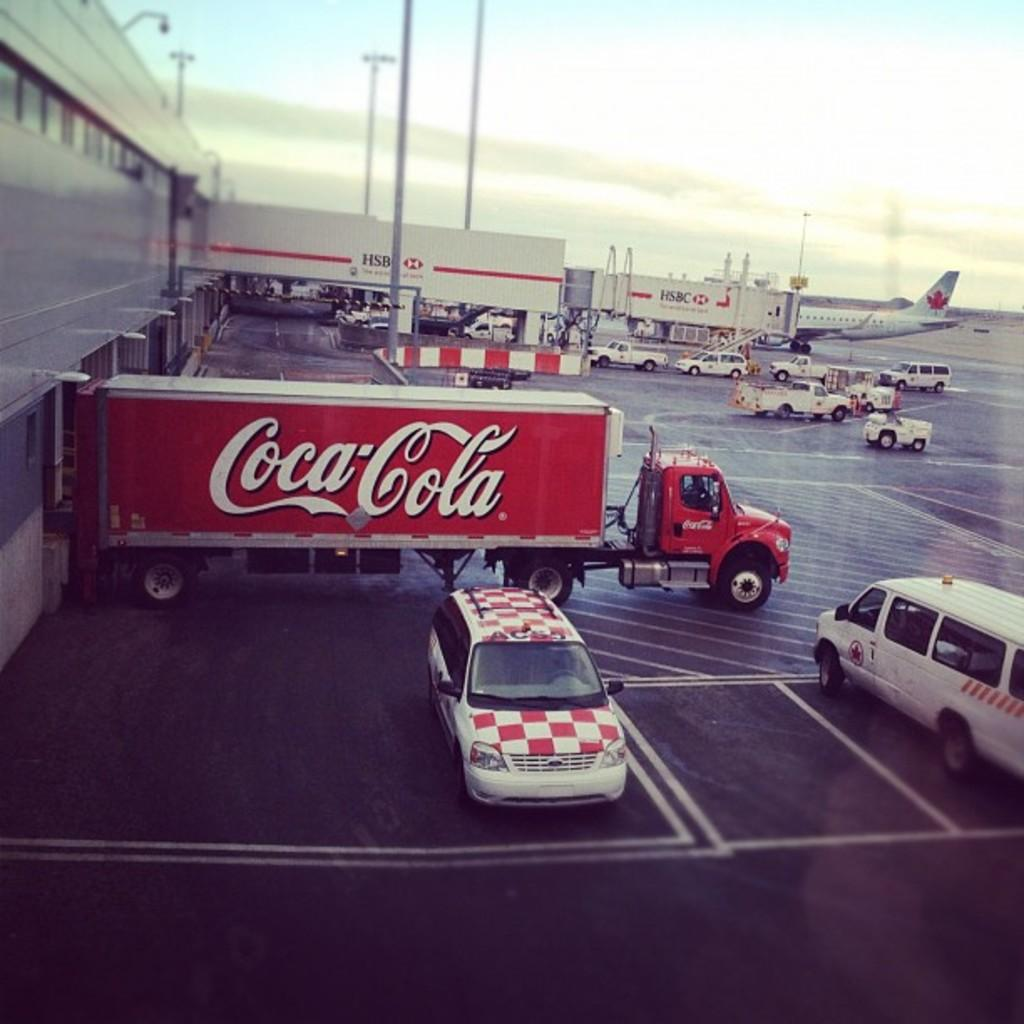Provide a one-sentence caption for the provided image. A coca cola truck sitting in a parking lot waitng to be loaded up. 